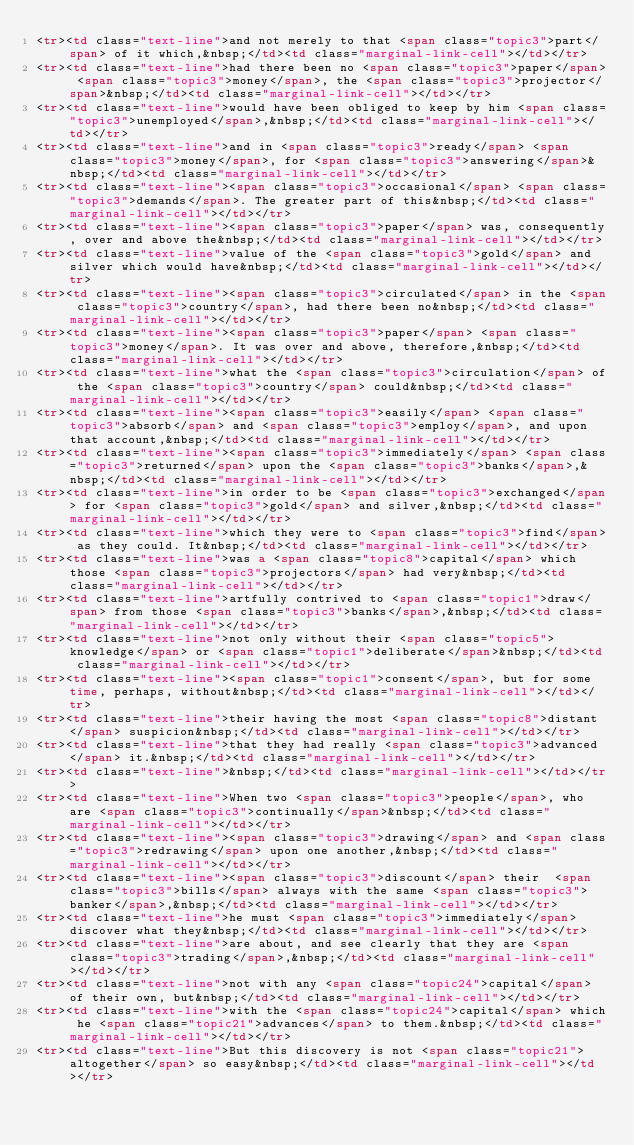Convert code to text. <code><loc_0><loc_0><loc_500><loc_500><_HTML_><tr><td class="text-line">and not merely to that <span class="topic3">part</span> of it which,&nbsp;</td><td class="marginal-link-cell"></td></tr>
<tr><td class="text-line">had there been no <span class="topic3">paper</span> <span class="topic3">money</span>, the <span class="topic3">projector</span>&nbsp;</td><td class="marginal-link-cell"></td></tr>
<tr><td class="text-line">would have been obliged to keep by him <span class="topic3">unemployed</span>,&nbsp;</td><td class="marginal-link-cell"></td></tr>
<tr><td class="text-line">and in <span class="topic3">ready</span> <span class="topic3">money</span>, for <span class="topic3">answering</span>&nbsp;</td><td class="marginal-link-cell"></td></tr>
<tr><td class="text-line"><span class="topic3">occasional</span> <span class="topic3">demands</span>. The greater part of this&nbsp;</td><td class="marginal-link-cell"></td></tr>
<tr><td class="text-line"><span class="topic3">paper</span> was, consequently, over and above the&nbsp;</td><td class="marginal-link-cell"></td></tr>
<tr><td class="text-line">value of the <span class="topic3">gold</span> and silver which would have&nbsp;</td><td class="marginal-link-cell"></td></tr>
<tr><td class="text-line"><span class="topic3">circulated</span> in the <span class="topic3">country</span>, had there been no&nbsp;</td><td class="marginal-link-cell"></td></tr>
<tr><td class="text-line"><span class="topic3">paper</span> <span class="topic3">money</span>. It was over and above, therefore,&nbsp;</td><td class="marginal-link-cell"></td></tr>
<tr><td class="text-line">what the <span class="topic3">circulation</span> of the <span class="topic3">country</span> could&nbsp;</td><td class="marginal-link-cell"></td></tr>
<tr><td class="text-line"><span class="topic3">easily</span> <span class="topic3">absorb</span> and <span class="topic3">employ</span>, and upon that account,&nbsp;</td><td class="marginal-link-cell"></td></tr>
<tr><td class="text-line"><span class="topic3">immediately</span> <span class="topic3">returned</span> upon the <span class="topic3">banks</span>,&nbsp;</td><td class="marginal-link-cell"></td></tr>
<tr><td class="text-line">in order to be <span class="topic3">exchanged</span> for <span class="topic3">gold</span> and silver,&nbsp;</td><td class="marginal-link-cell"></td></tr>
<tr><td class="text-line">which they were to <span class="topic3">find</span> as they could. It&nbsp;</td><td class="marginal-link-cell"></td></tr>
<tr><td class="text-line">was a <span class="topic8">capital</span> which those <span class="topic3">projectors</span> had very&nbsp;</td><td class="marginal-link-cell"></td></tr>
<tr><td class="text-line">artfully contrived to <span class="topic1">draw</span> from those <span class="topic3">banks</span>,&nbsp;</td><td class="marginal-link-cell"></td></tr>
<tr><td class="text-line">not only without their <span class="topic5">knowledge</span> or <span class="topic1">deliberate</span>&nbsp;</td><td class="marginal-link-cell"></td></tr>
<tr><td class="text-line"><span class="topic1">consent</span>, but for some time, perhaps, without&nbsp;</td><td class="marginal-link-cell"></td></tr>
<tr><td class="text-line">their having the most <span class="topic8">distant</span> suspicion&nbsp;</td><td class="marginal-link-cell"></td></tr>
<tr><td class="text-line">that they had really <span class="topic3">advanced</span> it.&nbsp;</td><td class="marginal-link-cell"></td></tr>
<tr><td class="text-line">&nbsp;</td><td class="marginal-link-cell"></td></tr>
<tr><td class="text-line">When two <span class="topic3">people</span>, who are <span class="topic3">continually</span>&nbsp;</td><td class="marginal-link-cell"></td></tr>
<tr><td class="text-line"><span class="topic3">drawing</span> and <span class="topic3">redrawing</span> upon one another,&nbsp;</td><td class="marginal-link-cell"></td></tr>
<tr><td class="text-line"><span class="topic3">discount</span> their  <span class="topic3">bills</span> always with the same <span class="topic3">banker</span>,&nbsp;</td><td class="marginal-link-cell"></td></tr>
<tr><td class="text-line">he must <span class="topic3">immediately</span> discover what they&nbsp;</td><td class="marginal-link-cell"></td></tr>
<tr><td class="text-line">are about, and see clearly that they are <span class="topic3">trading</span>,&nbsp;</td><td class="marginal-link-cell"></td></tr>
<tr><td class="text-line">not with any <span class="topic24">capital</span> of their own, but&nbsp;</td><td class="marginal-link-cell"></td></tr>
<tr><td class="text-line">with the <span class="topic24">capital</span> which he <span class="topic21">advances</span> to them.&nbsp;</td><td class="marginal-link-cell"></td></tr>
<tr><td class="text-line">But this discovery is not <span class="topic21">altogether</span> so easy&nbsp;</td><td class="marginal-link-cell"></td></tr></code> 